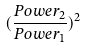Convert formula to latex. <formula><loc_0><loc_0><loc_500><loc_500>( \frac { P o w e r _ { 2 } } { P o w e r _ { 1 } } ) ^ { 2 }</formula> 